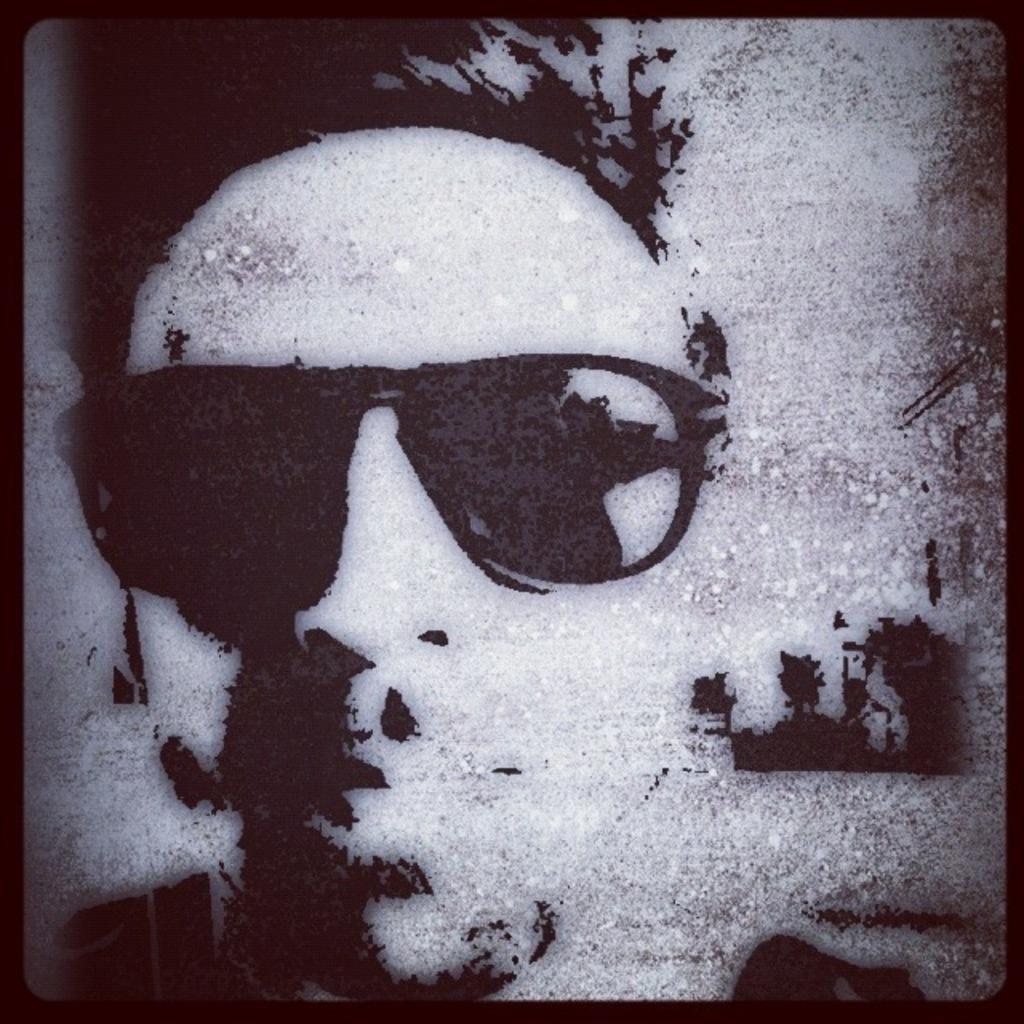In one or two sentences, can you explain what this image depicts? In this image, there is an art contains a person wearing sunglasses. 